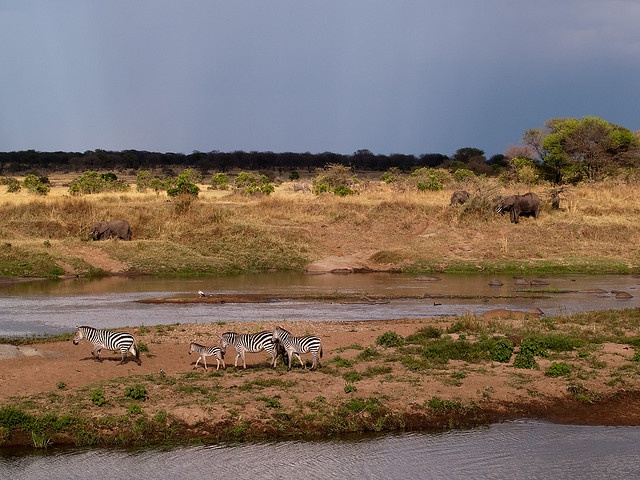Describe the objects in this image and their specific colors. I can see zebra in darkgray, black, gray, white, and maroon tones, zebra in darkgray, black, gray, and white tones, zebra in darkgray, black, gray, and ivory tones, elephant in darkgray, black, maroon, and gray tones, and elephant in darkgray, brown, maroon, and gray tones in this image. 